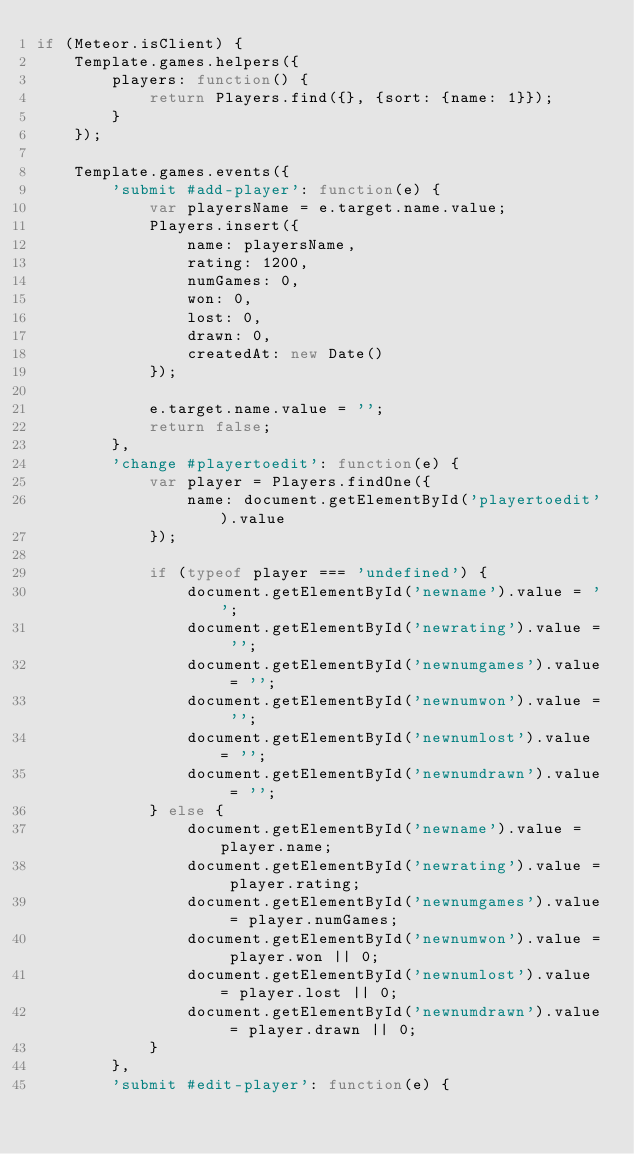<code> <loc_0><loc_0><loc_500><loc_500><_JavaScript_>if (Meteor.isClient) {
    Template.games.helpers({
        players: function() {
            return Players.find({}, {sort: {name: 1}});
        }
    });

    Template.games.events({
        'submit #add-player': function(e) {
            var playersName = e.target.name.value;
            Players.insert({
                name: playersName,
                rating: 1200,
                numGames: 0,
                won: 0,
                lost: 0,
                drawn: 0,
                createdAt: new Date()
            });

            e.target.name.value = '';
            return false;
        },
        'change #playertoedit': function(e) {
            var player = Players.findOne({
                name: document.getElementById('playertoedit').value
            });

            if (typeof player === 'undefined') {
                document.getElementById('newname').value = '';
                document.getElementById('newrating').value = '';
                document.getElementById('newnumgames').value = '';
                document.getElementById('newnumwon').value = '';
                document.getElementById('newnumlost').value = '';
                document.getElementById('newnumdrawn').value = '';
            } else {
                document.getElementById('newname').value = player.name;
                document.getElementById('newrating').value = player.rating;
                document.getElementById('newnumgames').value = player.numGames;
                document.getElementById('newnumwon').value = player.won || 0;
                document.getElementById('newnumlost').value = player.lost || 0;
                document.getElementById('newnumdrawn').value = player.drawn || 0;
            }
        },
        'submit #edit-player': function(e) {</code> 